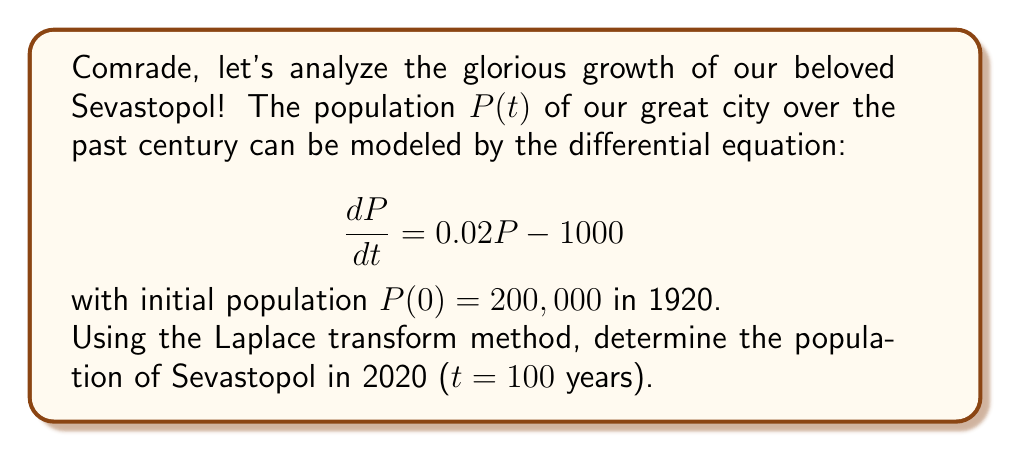Give your solution to this math problem. Let's solve this step-by-step using Laplace transforms:

1) Take the Laplace transform of both sides of the equation:
   $$\mathcal{L}\left\{\frac{dP}{dt}\right\} = \mathcal{L}\{0.02P - 1000\}$$

2) Using Laplace transform properties:
   $$sP(s) - P(0) = 0.02P(s) - \frac{1000}{s}$$

3) Substitute P(0) = 200,000:
   $$sP(s) - 200,000 = 0.02P(s) - \frac{1000}{s}$$

4) Rearrange terms:
   $$(s - 0.02)P(s) = 200,000 + \frac{1000}{s}$$

5) Solve for P(s):
   $$P(s) = \frac{200,000}{s - 0.02} + \frac{1000}{s(s - 0.02)}$$

6) Perform partial fraction decomposition:
   $$P(s) = \frac{A}{s} + \frac{B}{s - 0.02}$$
   where A = 50,000 and B = 200,000

7) Take the inverse Laplace transform:
   $$P(t) = 50,000 + 200,000e^{0.02t}$$

8) Evaluate P(t) at t = 100:
   $$P(100) = 50,000 + 200,000e^{2} \approx 1,486,551$$

Therefore, the population of Sevastopol in 2020 is approximately 1,486,551 people.
Answer: 1,486,551 people 